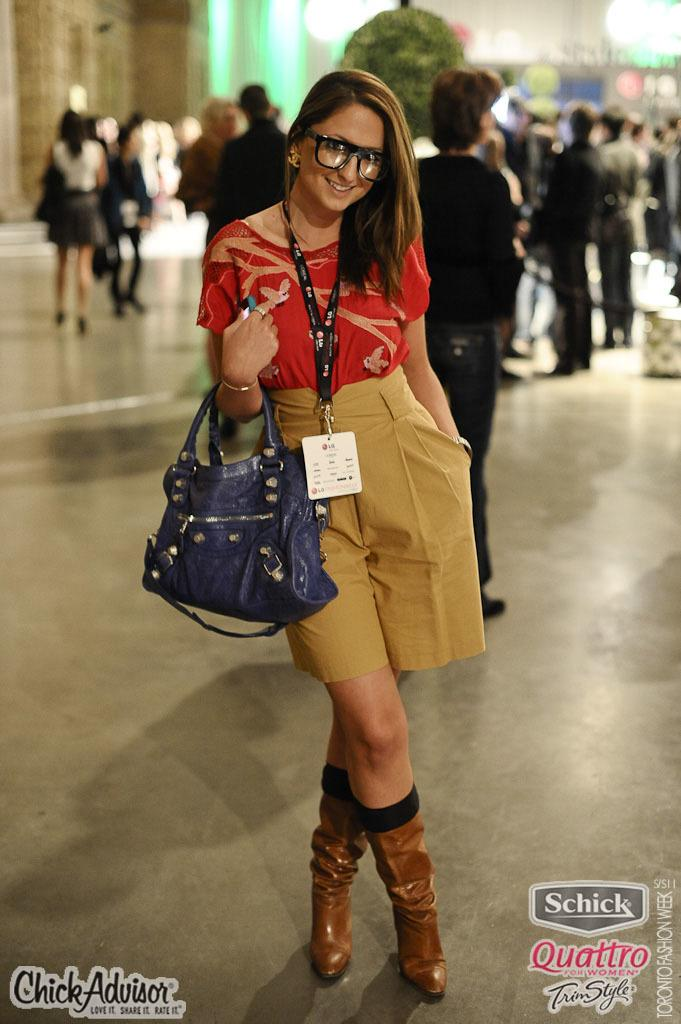What is the main subject of the image? The main subject of the image is a woman. What is the woman doing in the image? The woman is standing in the image. What is the woman wearing that might identify her? The woman is wearing an ID card in the image. What accessory is the woman carrying? The woman is carrying a handbag in the image. Can you describe the background of the image? In the background of the image, there are more people, some of whom are walking and others who are standing. What type of poisonous plant can be seen in the image? There is no poisonous plant present in the image. What agreement was reached between the woman and the people in the background? There is no indication of any agreement in the image. 